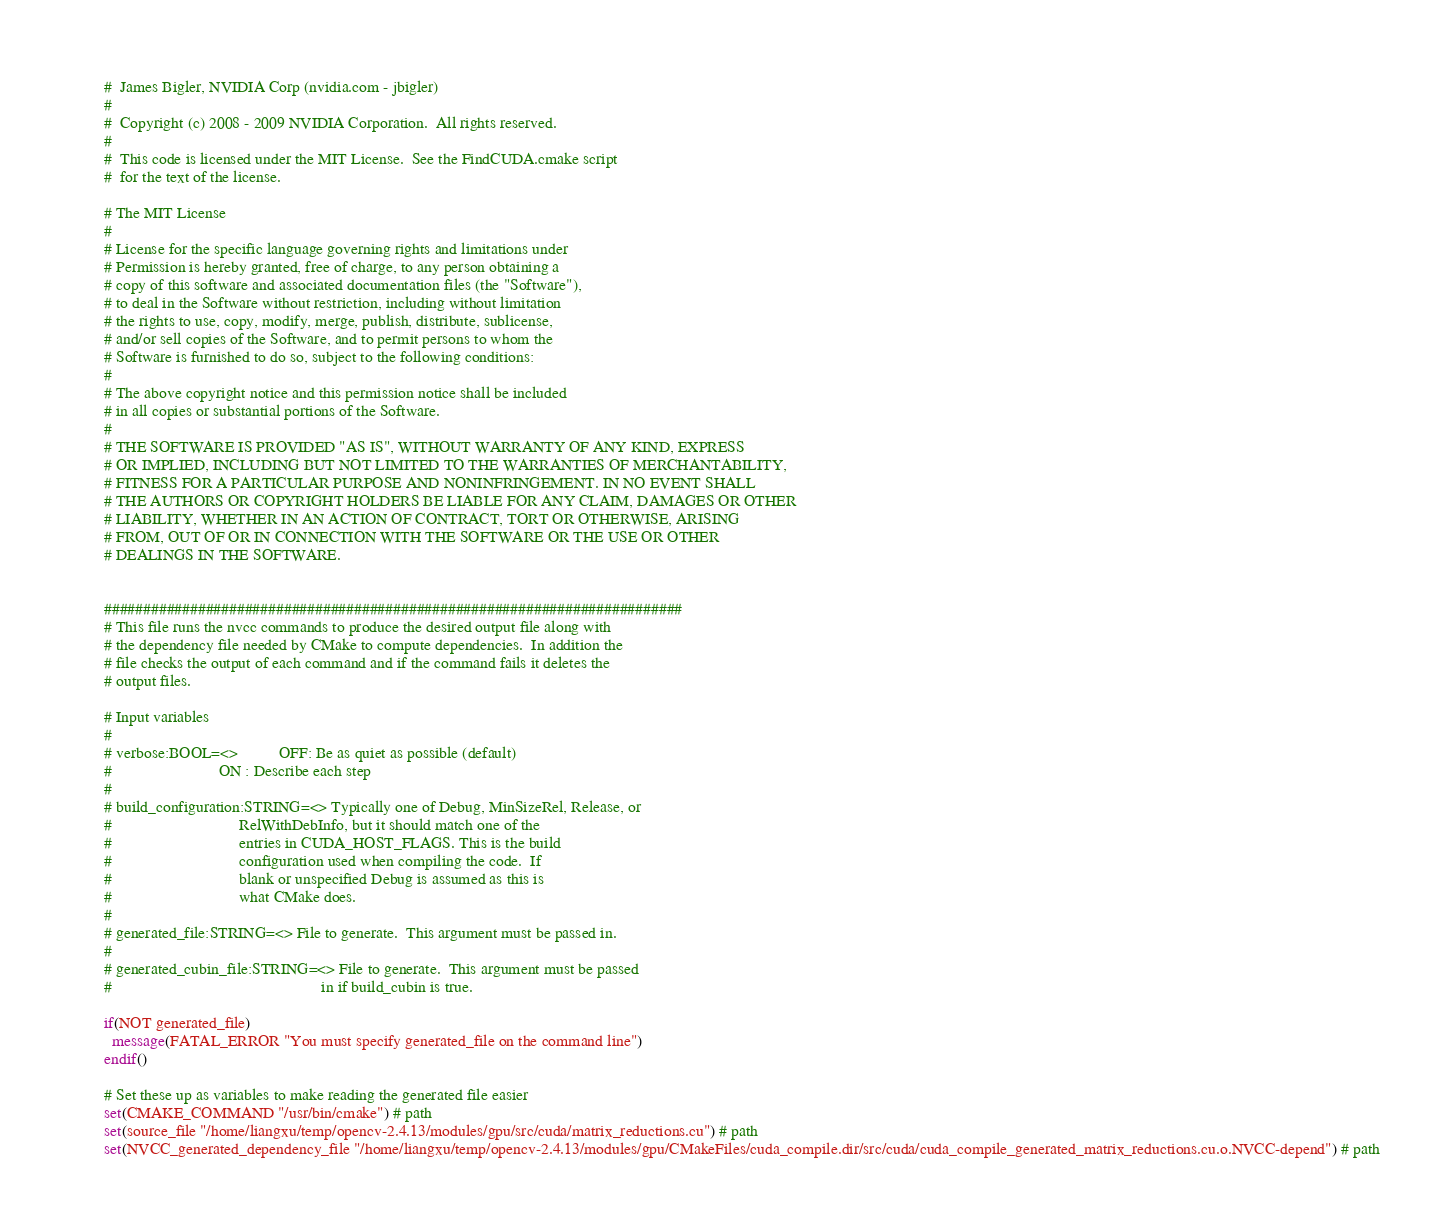Convert code to text. <code><loc_0><loc_0><loc_500><loc_500><_CMake_>#  James Bigler, NVIDIA Corp (nvidia.com - jbigler)
#
#  Copyright (c) 2008 - 2009 NVIDIA Corporation.  All rights reserved.
#
#  This code is licensed under the MIT License.  See the FindCUDA.cmake script
#  for the text of the license.

# The MIT License
#
# License for the specific language governing rights and limitations under
# Permission is hereby granted, free of charge, to any person obtaining a
# copy of this software and associated documentation files (the "Software"),
# to deal in the Software without restriction, including without limitation
# the rights to use, copy, modify, merge, publish, distribute, sublicense,
# and/or sell copies of the Software, and to permit persons to whom the
# Software is furnished to do so, subject to the following conditions:
#
# The above copyright notice and this permission notice shall be included
# in all copies or substantial portions of the Software.
#
# THE SOFTWARE IS PROVIDED "AS IS", WITHOUT WARRANTY OF ANY KIND, EXPRESS
# OR IMPLIED, INCLUDING BUT NOT LIMITED TO THE WARRANTIES OF MERCHANTABILITY,
# FITNESS FOR A PARTICULAR PURPOSE AND NONINFRINGEMENT. IN NO EVENT SHALL
# THE AUTHORS OR COPYRIGHT HOLDERS BE LIABLE FOR ANY CLAIM, DAMAGES OR OTHER
# LIABILITY, WHETHER IN AN ACTION OF CONTRACT, TORT OR OTHERWISE, ARISING
# FROM, OUT OF OR IN CONNECTION WITH THE SOFTWARE OR THE USE OR OTHER
# DEALINGS IN THE SOFTWARE.


##########################################################################
# This file runs the nvcc commands to produce the desired output file along with
# the dependency file needed by CMake to compute dependencies.  In addition the
# file checks the output of each command and if the command fails it deletes the
# output files.

# Input variables
#
# verbose:BOOL=<>          OFF: Be as quiet as possible (default)
#                          ON : Describe each step
#
# build_configuration:STRING=<> Typically one of Debug, MinSizeRel, Release, or
#                               RelWithDebInfo, but it should match one of the
#                               entries in CUDA_HOST_FLAGS. This is the build
#                               configuration used when compiling the code.  If
#                               blank or unspecified Debug is assumed as this is
#                               what CMake does.
#
# generated_file:STRING=<> File to generate.  This argument must be passed in.
#
# generated_cubin_file:STRING=<> File to generate.  This argument must be passed
#                                                   in if build_cubin is true.

if(NOT generated_file)
  message(FATAL_ERROR "You must specify generated_file on the command line")
endif()

# Set these up as variables to make reading the generated file easier
set(CMAKE_COMMAND "/usr/bin/cmake") # path
set(source_file "/home/liangxu/temp/opencv-2.4.13/modules/gpu/src/cuda/matrix_reductions.cu") # path
set(NVCC_generated_dependency_file "/home/liangxu/temp/opencv-2.4.13/modules/gpu/CMakeFiles/cuda_compile.dir/src/cuda/cuda_compile_generated_matrix_reductions.cu.o.NVCC-depend") # path</code> 